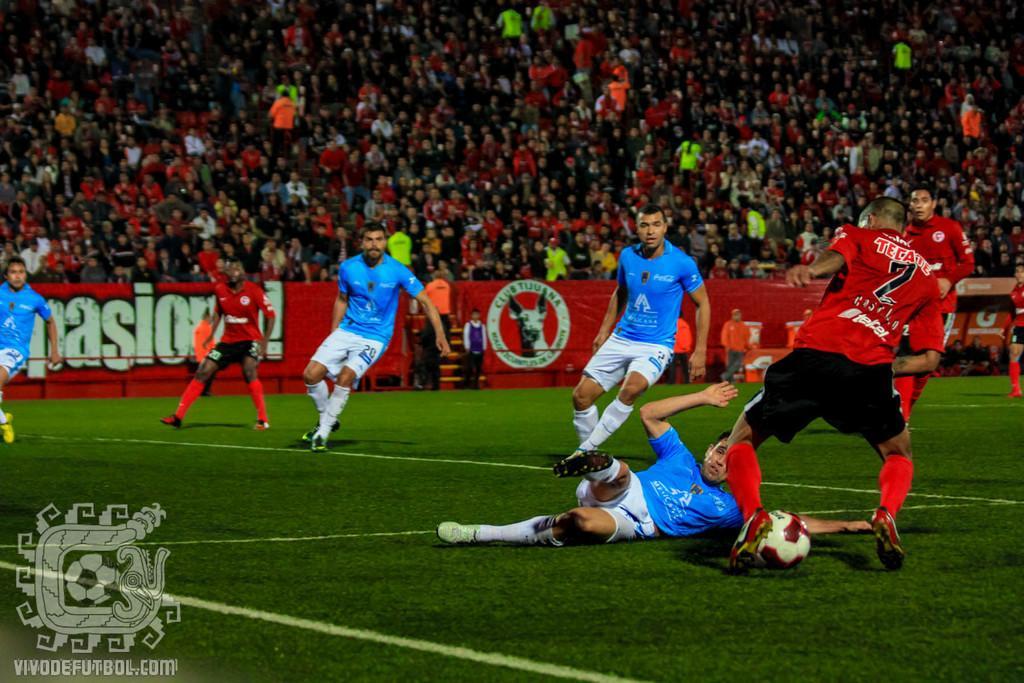Please provide a concise description of this image. In this image I can see a stadium. In the stadium where are the people playing the football. To the back of them there is a banner and the stairs. In the background there are group of people sitting inside the stadium. 